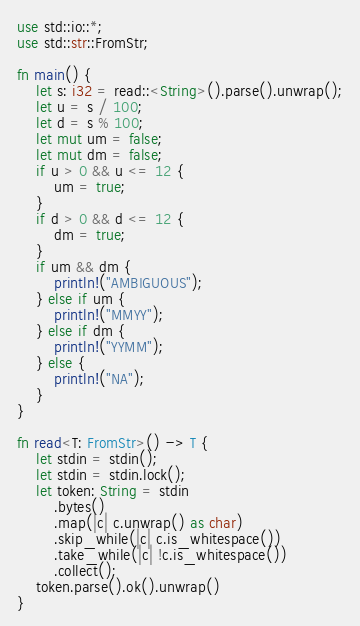Convert code to text. <code><loc_0><loc_0><loc_500><loc_500><_Rust_>use std::io::*;
use std::str::FromStr;

fn main() {
    let s: i32 = read::<String>().parse().unwrap();
    let u = s / 100;
    let d = s % 100;
    let mut um = false;
    let mut dm = false;
    if u > 0 && u <= 12 {
        um = true;
    }
    if d > 0 && d <= 12 {
        dm = true;
    }
    if um && dm {
        println!("AMBIGUOUS");
    } else if um {
        println!("MMYY");
    } else if dm {
        println!("YYMM");
    } else {
        println!("NA");
    }
}

fn read<T: FromStr>() -> T {
    let stdin = stdin();
    let stdin = stdin.lock();
    let token: String = stdin
        .bytes()
        .map(|c| c.unwrap() as char)
        .skip_while(|c| c.is_whitespace())
        .take_while(|c| !c.is_whitespace())
        .collect();
    token.parse().ok().unwrap()
}
</code> 